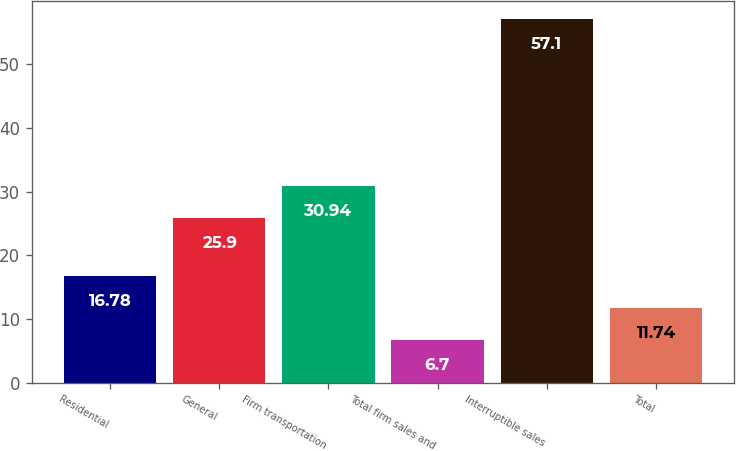Convert chart. <chart><loc_0><loc_0><loc_500><loc_500><bar_chart><fcel>Residential<fcel>General<fcel>Firm transportation<fcel>Total firm sales and<fcel>Interruptible sales<fcel>Total<nl><fcel>16.78<fcel>25.9<fcel>30.94<fcel>6.7<fcel>57.1<fcel>11.74<nl></chart> 